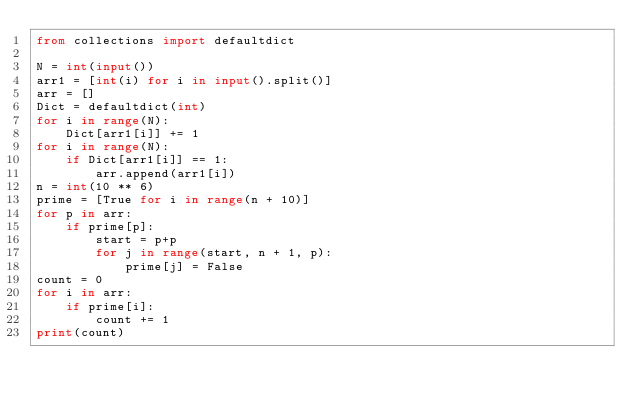Convert code to text. <code><loc_0><loc_0><loc_500><loc_500><_Python_>from collections import defaultdict

N = int(input())
arr1 = [int(i) for i in input().split()]
arr = []
Dict = defaultdict(int)
for i in range(N):
    Dict[arr1[i]] += 1
for i in range(N):
    if Dict[arr1[i]] == 1:
        arr.append(arr1[i])
n = int(10 ** 6)
prime = [True for i in range(n + 10)]
for p in arr:
    if prime[p]:
        start = p+p
        for j in range(start, n + 1, p):
            prime[j] = False
count = 0
for i in arr:
    if prime[i]:
        count += 1
print(count)
</code> 